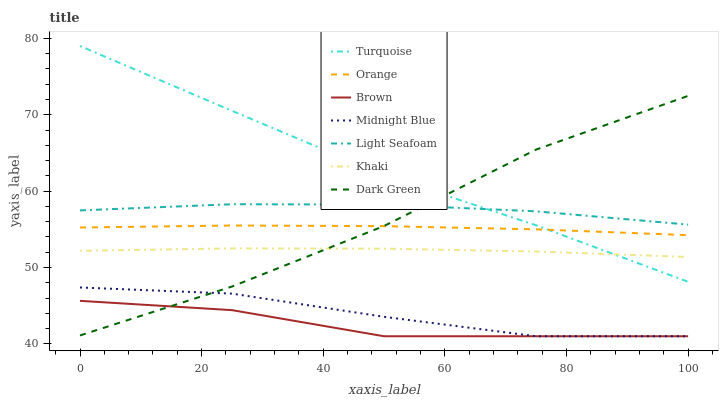Does Brown have the minimum area under the curve?
Answer yes or no. Yes. Does Turquoise have the maximum area under the curve?
Answer yes or no. Yes. Does Khaki have the minimum area under the curve?
Answer yes or no. No. Does Khaki have the maximum area under the curve?
Answer yes or no. No. Is Orange the smoothest?
Answer yes or no. Yes. Is Dark Green the roughest?
Answer yes or no. Yes. Is Turquoise the smoothest?
Answer yes or no. No. Is Turquoise the roughest?
Answer yes or no. No. Does Turquoise have the lowest value?
Answer yes or no. No. Does Turquoise have the highest value?
Answer yes or no. Yes. Does Khaki have the highest value?
Answer yes or no. No. Is Brown less than Turquoise?
Answer yes or no. Yes. Is Light Seafoam greater than Brown?
Answer yes or no. Yes. Does Turquoise intersect Light Seafoam?
Answer yes or no. Yes. Is Turquoise less than Light Seafoam?
Answer yes or no. No. Is Turquoise greater than Light Seafoam?
Answer yes or no. No. Does Brown intersect Turquoise?
Answer yes or no. No. 